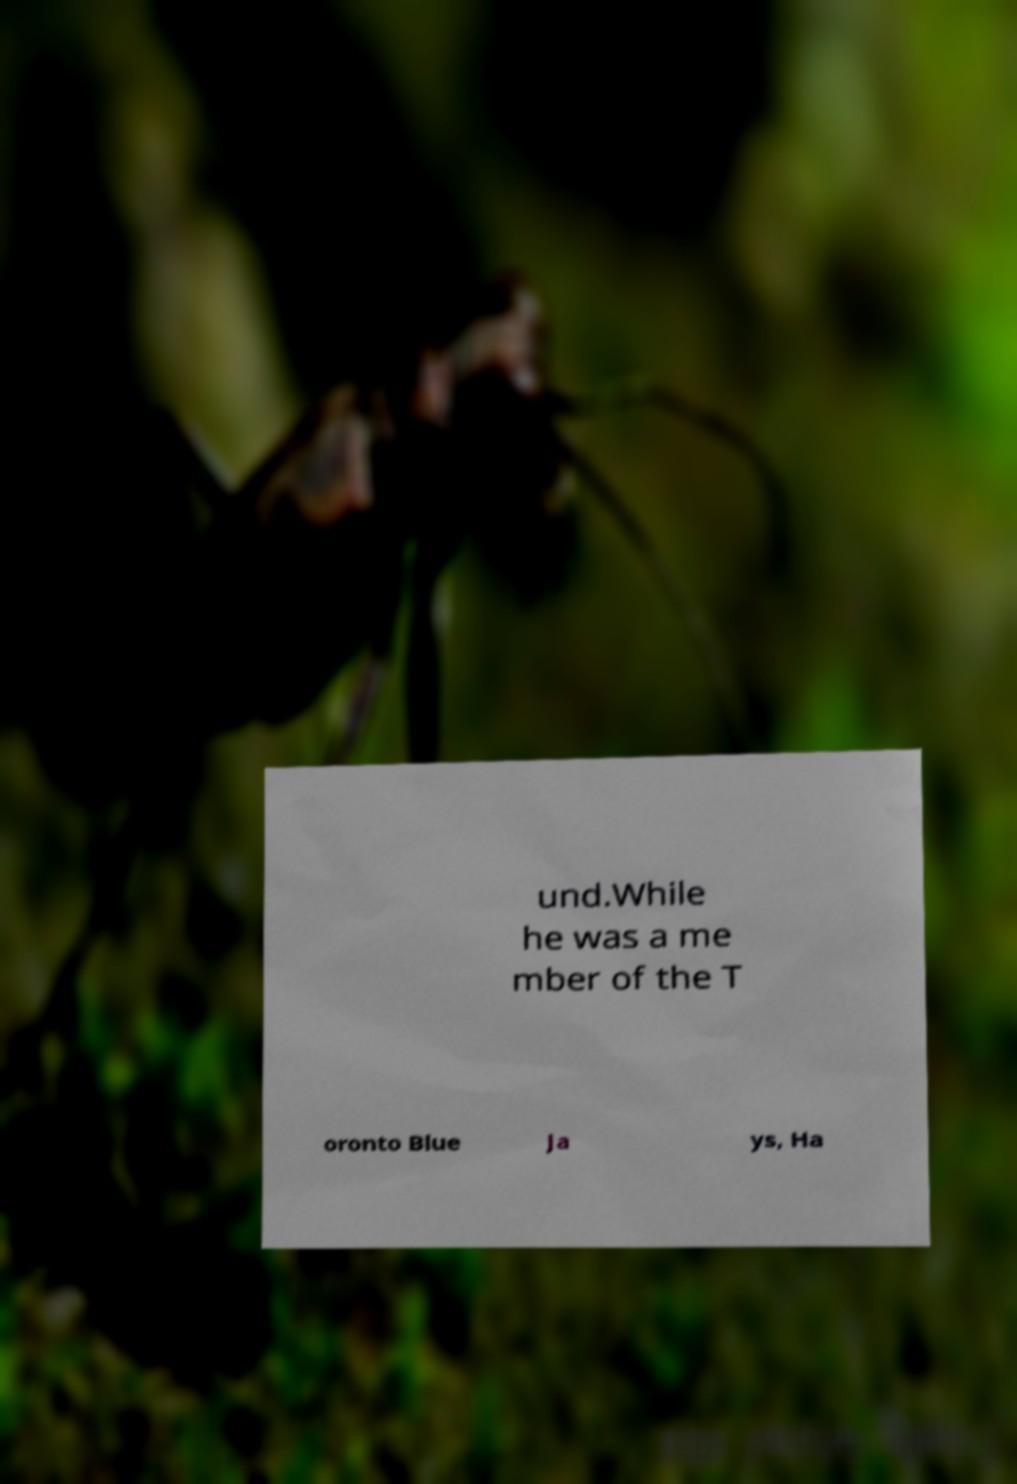There's text embedded in this image that I need extracted. Can you transcribe it verbatim? und.While he was a me mber of the T oronto Blue Ja ys, Ha 